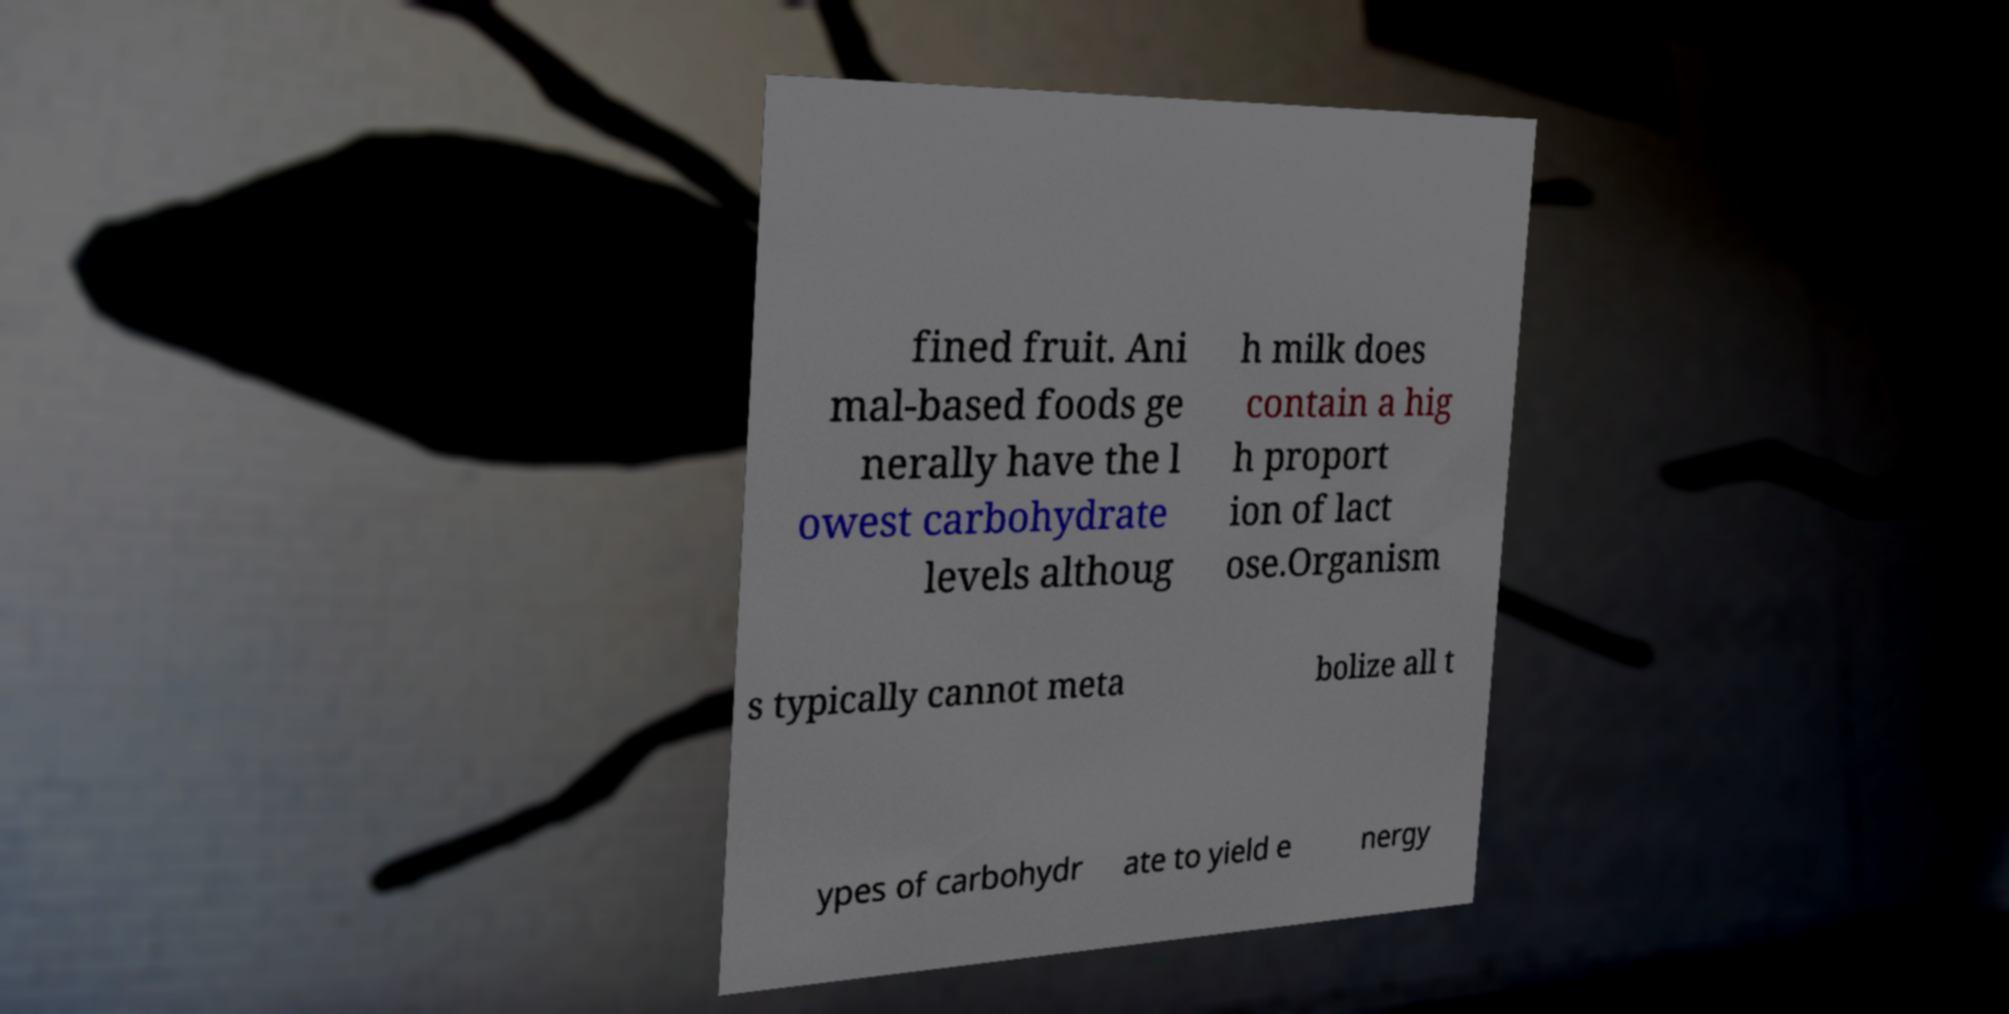Can you accurately transcribe the text from the provided image for me? fined fruit. Ani mal-based foods ge nerally have the l owest carbohydrate levels althoug h milk does contain a hig h proport ion of lact ose.Organism s typically cannot meta bolize all t ypes of carbohydr ate to yield e nergy 